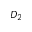Convert formula to latex. <formula><loc_0><loc_0><loc_500><loc_500>D _ { 2 }</formula> 